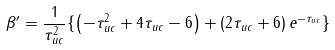Convert formula to latex. <formula><loc_0><loc_0><loc_500><loc_500>\beta ^ { \prime } = \frac { 1 } { \tau _ { u c } ^ { 2 } } \{ \left ( - \tau _ { u c } ^ { 2 } + 4 \tau _ { u c } - 6 \right ) + \left ( 2 \tau _ { u c } + 6 \right ) e ^ { - \tau _ { u c } } \}</formula> 